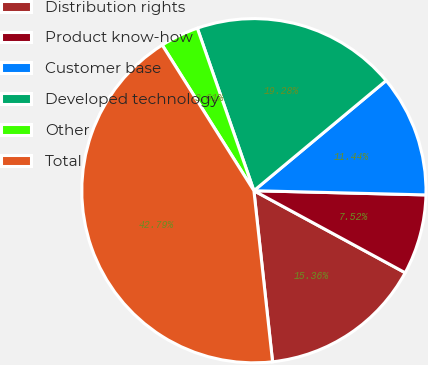<chart> <loc_0><loc_0><loc_500><loc_500><pie_chart><fcel>Distribution rights<fcel>Product know-how<fcel>Customer base<fcel>Developed technology<fcel>Other<fcel>Total<nl><fcel>15.36%<fcel>7.52%<fcel>11.44%<fcel>19.28%<fcel>3.61%<fcel>42.79%<nl></chart> 